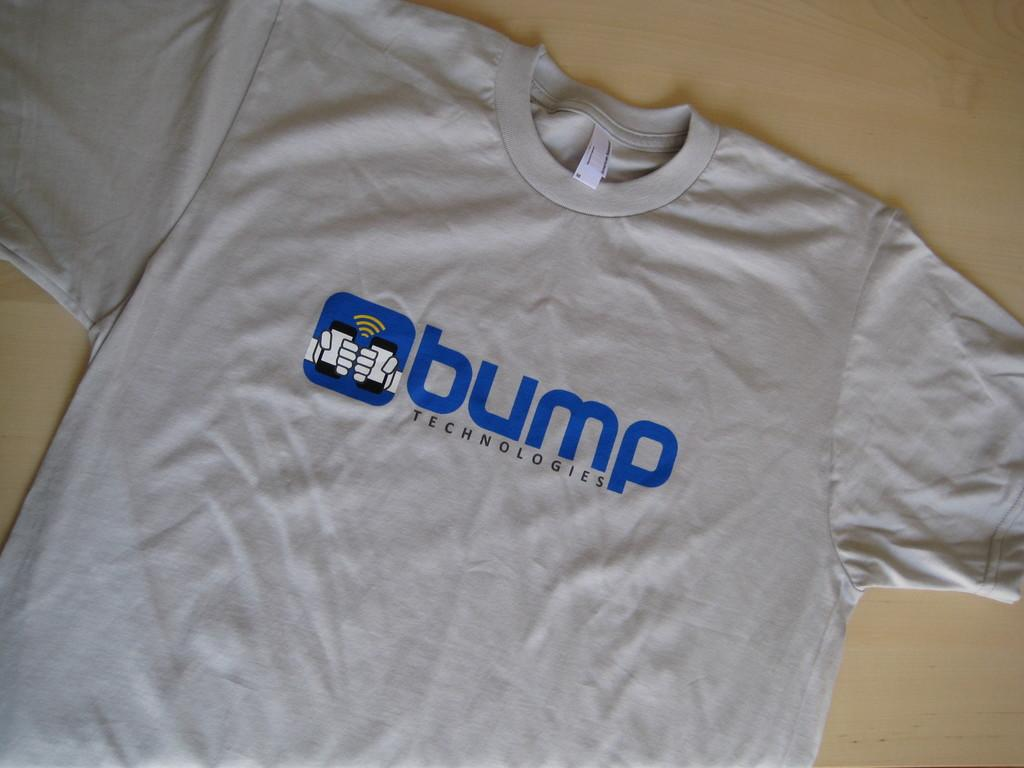<image>
Present a compact description of the photo's key features. the word bump is on the shirt that is white 